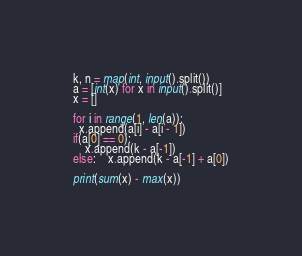Convert code to text. <code><loc_0><loc_0><loc_500><loc_500><_Python_>k, n = map(int, input().split())
a = [int(x) for x in input().split()]
x = []

for i in range(1, len(a)):
  x.append(a[i] - a[i - 1])
if(a[0] == 0):
	x.append(k - a[-1])
else:	x.append(k - a[-1] + a[0])

print(sum(x) - max(x))</code> 